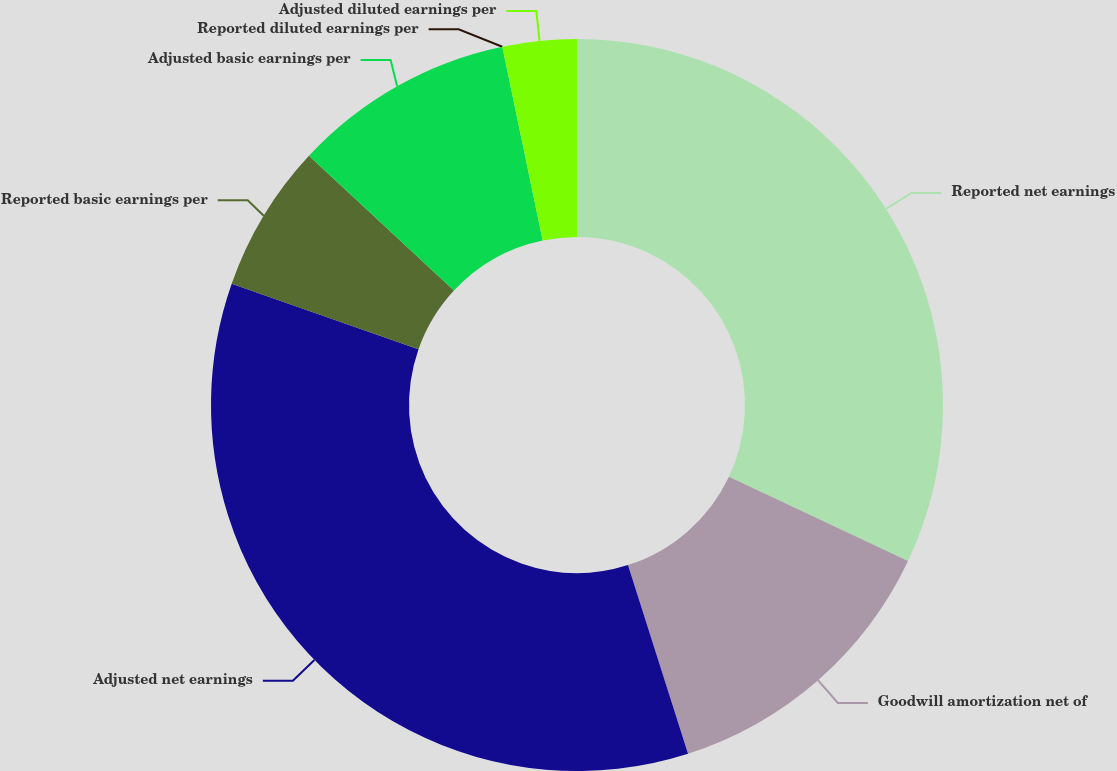<chart> <loc_0><loc_0><loc_500><loc_500><pie_chart><fcel>Reported net earnings<fcel>Goodwill amortization net of<fcel>Adjusted net earnings<fcel>Reported basic earnings per<fcel>Adjusted basic earnings per<fcel>Reported diluted earnings per<fcel>Adjusted diluted earnings per<nl><fcel>32.01%<fcel>13.08%<fcel>35.28%<fcel>6.54%<fcel>9.81%<fcel>0.0%<fcel>3.27%<nl></chart> 